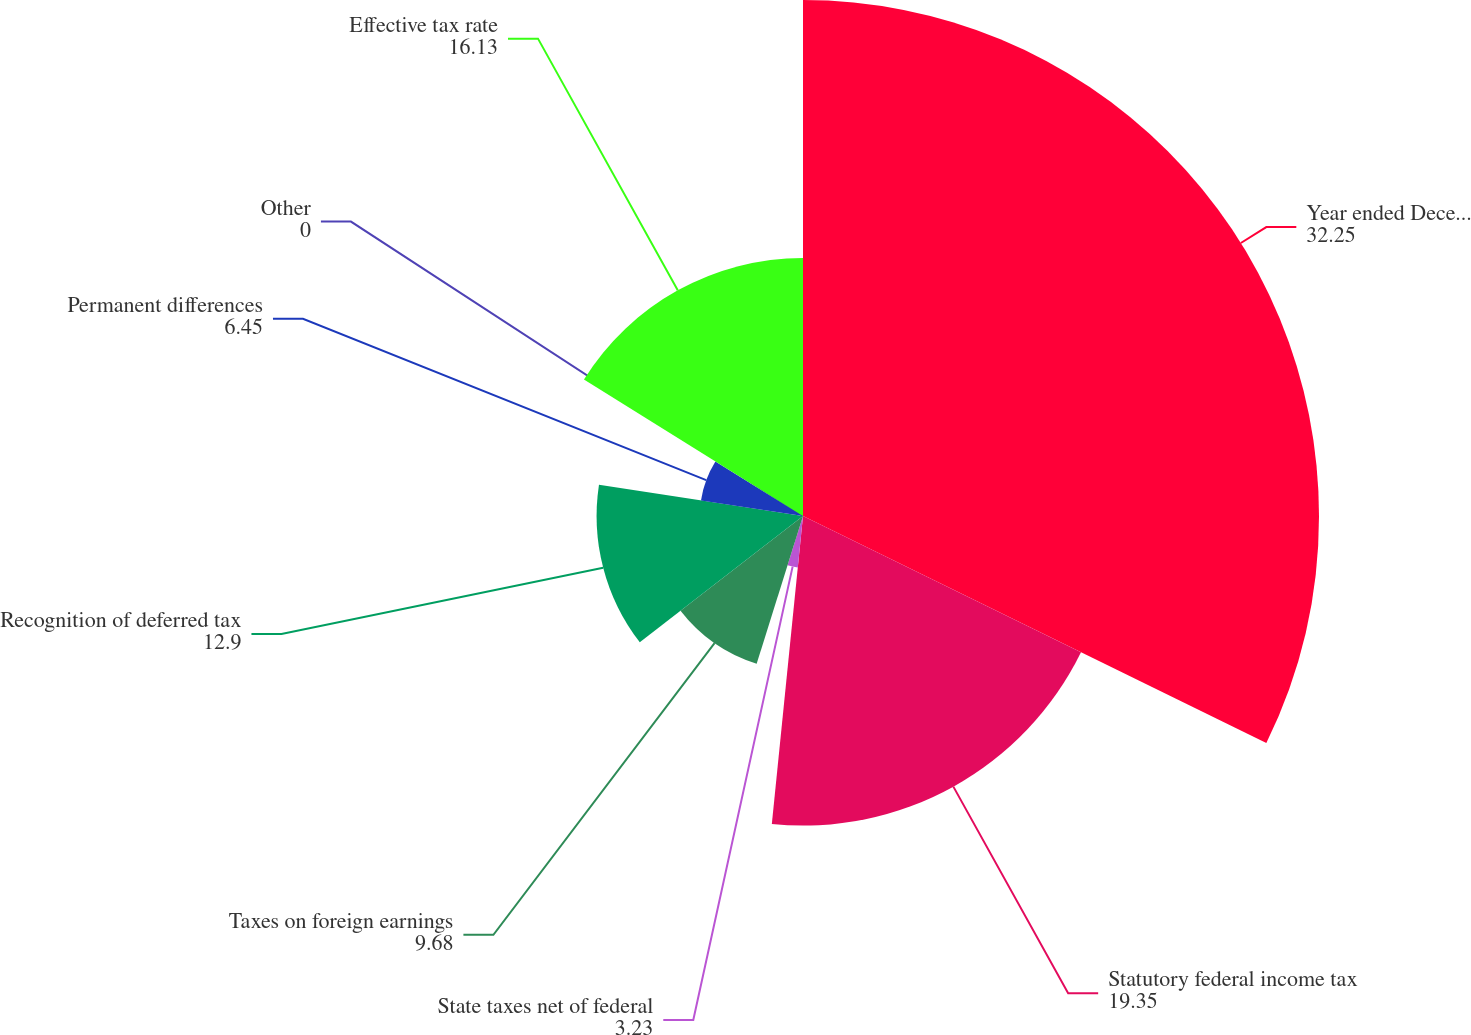Convert chart. <chart><loc_0><loc_0><loc_500><loc_500><pie_chart><fcel>Year ended December 31<fcel>Statutory federal income tax<fcel>State taxes net of federal<fcel>Taxes on foreign earnings<fcel>Recognition of deferred tax<fcel>Permanent differences<fcel>Other<fcel>Effective tax rate<nl><fcel>32.25%<fcel>19.35%<fcel>3.23%<fcel>9.68%<fcel>12.9%<fcel>6.45%<fcel>0.0%<fcel>16.13%<nl></chart> 